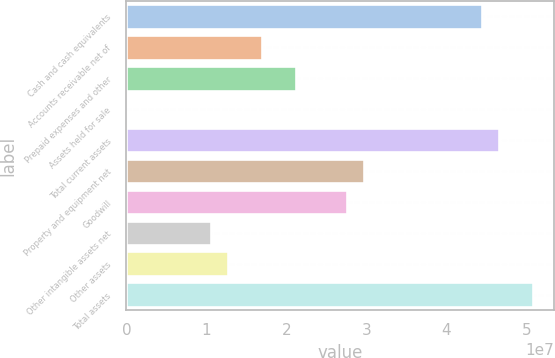Convert chart. <chart><loc_0><loc_0><loc_500><loc_500><bar_chart><fcel>Cash and cash equivalents<fcel>Accounts receivable net of<fcel>Prepaid expenses and other<fcel>Assets held for sale<fcel>Total current assets<fcel>Property and equipment net<fcel>Goodwill<fcel>Other intangible assets net<fcel>Other assets<fcel>Total assets<nl><fcel>4.45072e+07<fcel>1.69558e+07<fcel>2.11944e+07<fcel>1043<fcel>4.66265e+07<fcel>2.96718e+07<fcel>2.75525e+07<fcel>1.05977e+07<fcel>1.27171e+07<fcel>5.08652e+07<nl></chart> 